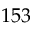Convert formula to latex. <formula><loc_0><loc_0><loc_500><loc_500>1 5 3</formula> 